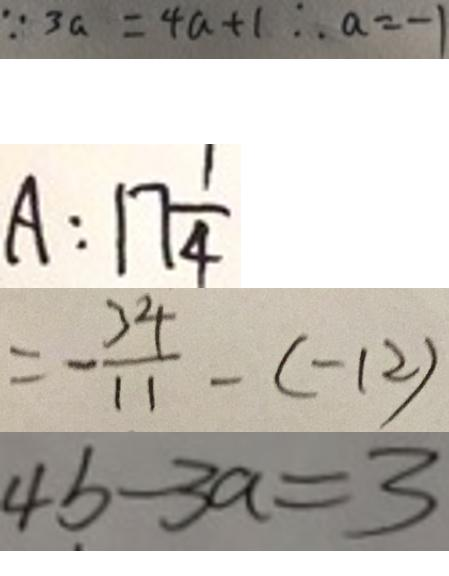<formula> <loc_0><loc_0><loc_500><loc_500>\because 3 a = 4 a + 1 \therefore a = - 1 
 A : 1 7 \frac { 1 } { 4 } 
 = - \frac { 3 4 } { 1 1 } - ( - 1 2 ) 
 4 b - 3 a = 3</formula> 